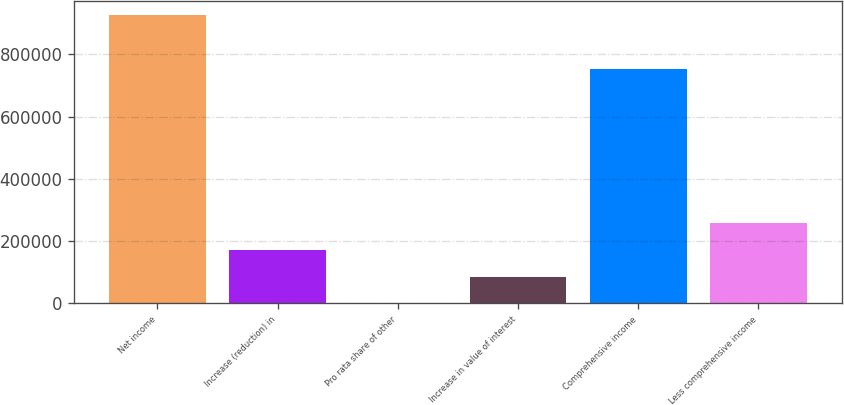Convert chart to OTSL. <chart><loc_0><loc_0><loc_500><loc_500><bar_chart><fcel>Net income<fcel>Increase (reduction) in<fcel>Pro rata share of other<fcel>Increase in value of interest<fcel>Comprehensive income<fcel>Less comprehensive income<nl><fcel>926274<fcel>172148<fcel>327<fcel>86237.3<fcel>754453<fcel>258058<nl></chart> 